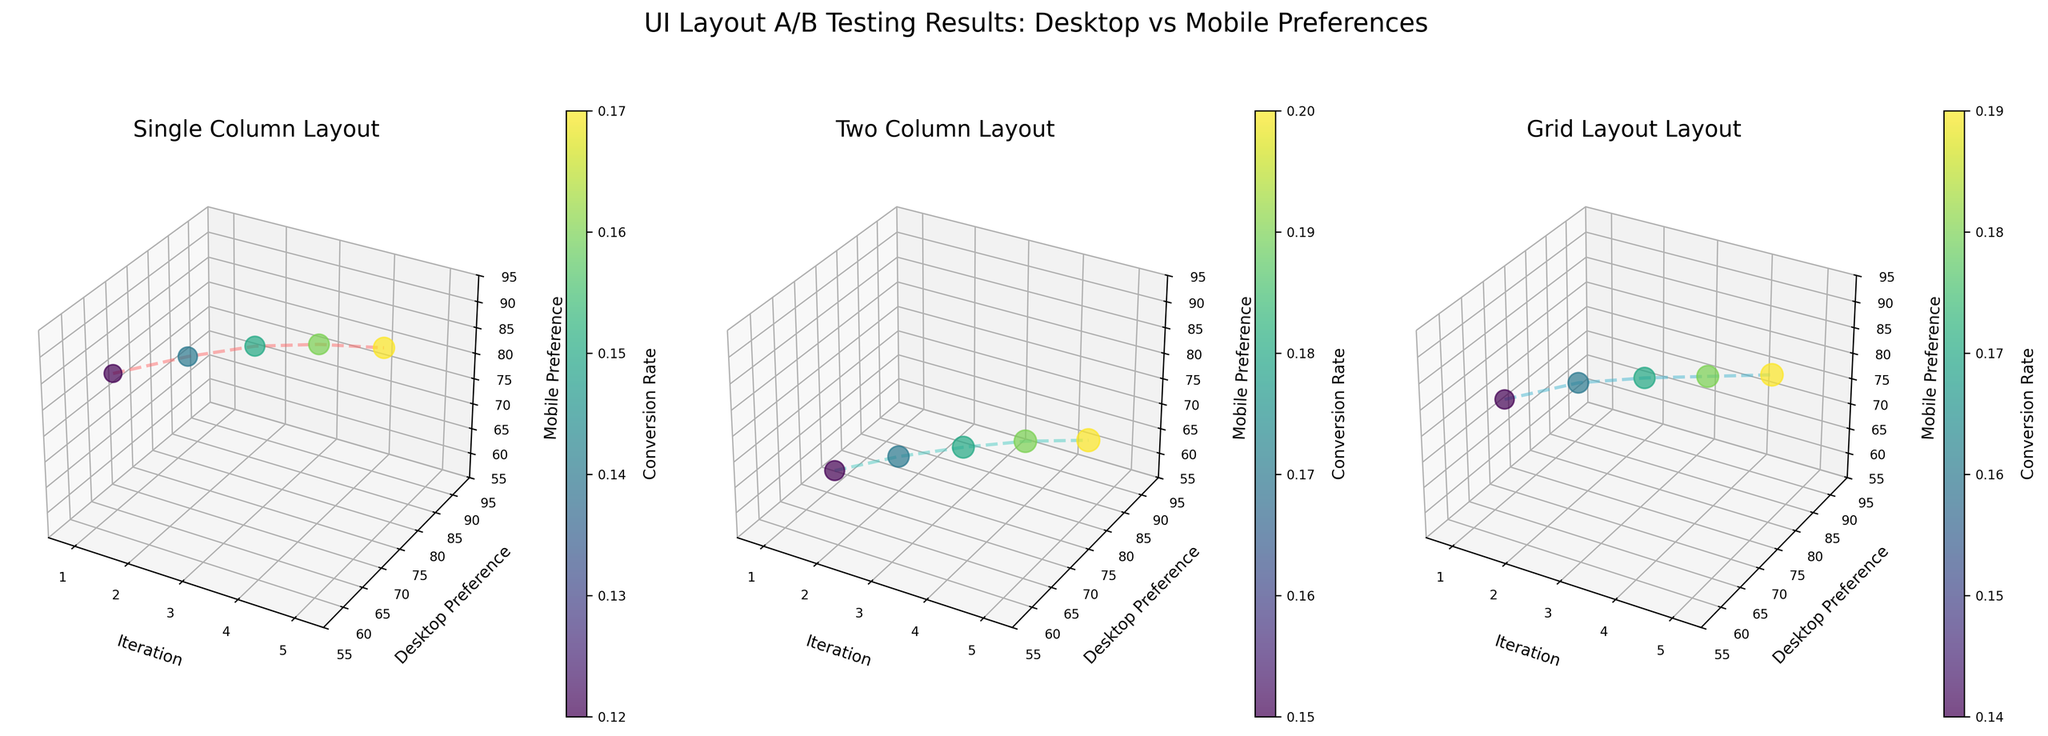What's the title of the figure? The title of the figure is displayed at the top and reads 'UI Layout A/B Testing Results: Desktop vs Mobile Preferences'.
Answer: UI Layout A/B Testing Results: Desktop vs Mobile Preferences How many subplots are there in the figure? There are three subplots, one for each type of layout: Single Column, Two Column, and Grid Layout.
Answer: 3 Which layout has the highest desktop preference in the 5th iteration? In the fifth subplot for the Two Column layout, the desktop preference reaches the peak value of 82.
Answer: Two Column Which subplot has the smallest range of desktop preference values between iterations 1 to 5? The Single Column layout ranges from 65 to 77, which is a smaller range compared to the other layouts.
Answer: Single Column What is the mobile preference for the Grid Layout in the 2nd iteration? In the subplot for the Grid Layout, the mobile preference for the 2nd iteration is shown as 78.
Answer: 78 Which iteration has the highest conversion rate in the Single Column layout? The fifth iteration shows the highest conversion rate of 0.17 for the Single Column layout as indicated by the larger size of the data point.
Answer: 5 How does the conversion rate change across iterations for the Two Column layout? The conversion rate increases from 0.15 in the first iteration to 0.20 in the fifth iteration for the Two Column layout, as observed from the increasing size of the data points and corresponding color intensity.
Answer: Increases Compare the mobile preferences for Single Column and Two Column layouts in the third iteration. Which one is higher? The Single Column layout has a mobile preference of 88, while the Two Column layout has 65 in the third iteration. The Single Column layout has a higher value.
Answer: Single Column What's the average conversion rate for the Grid Layout across all iterations? The conversion rates for Grid Layout across iterations are 0.14, 0.16, 0.17, 0.18, and 0.19. Summing them up gives 0.84, and the average is 0.84 / 5 = 0.168.
Answer: 0.168 